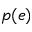Convert formula to latex. <formula><loc_0><loc_0><loc_500><loc_500>p ( e )</formula> 